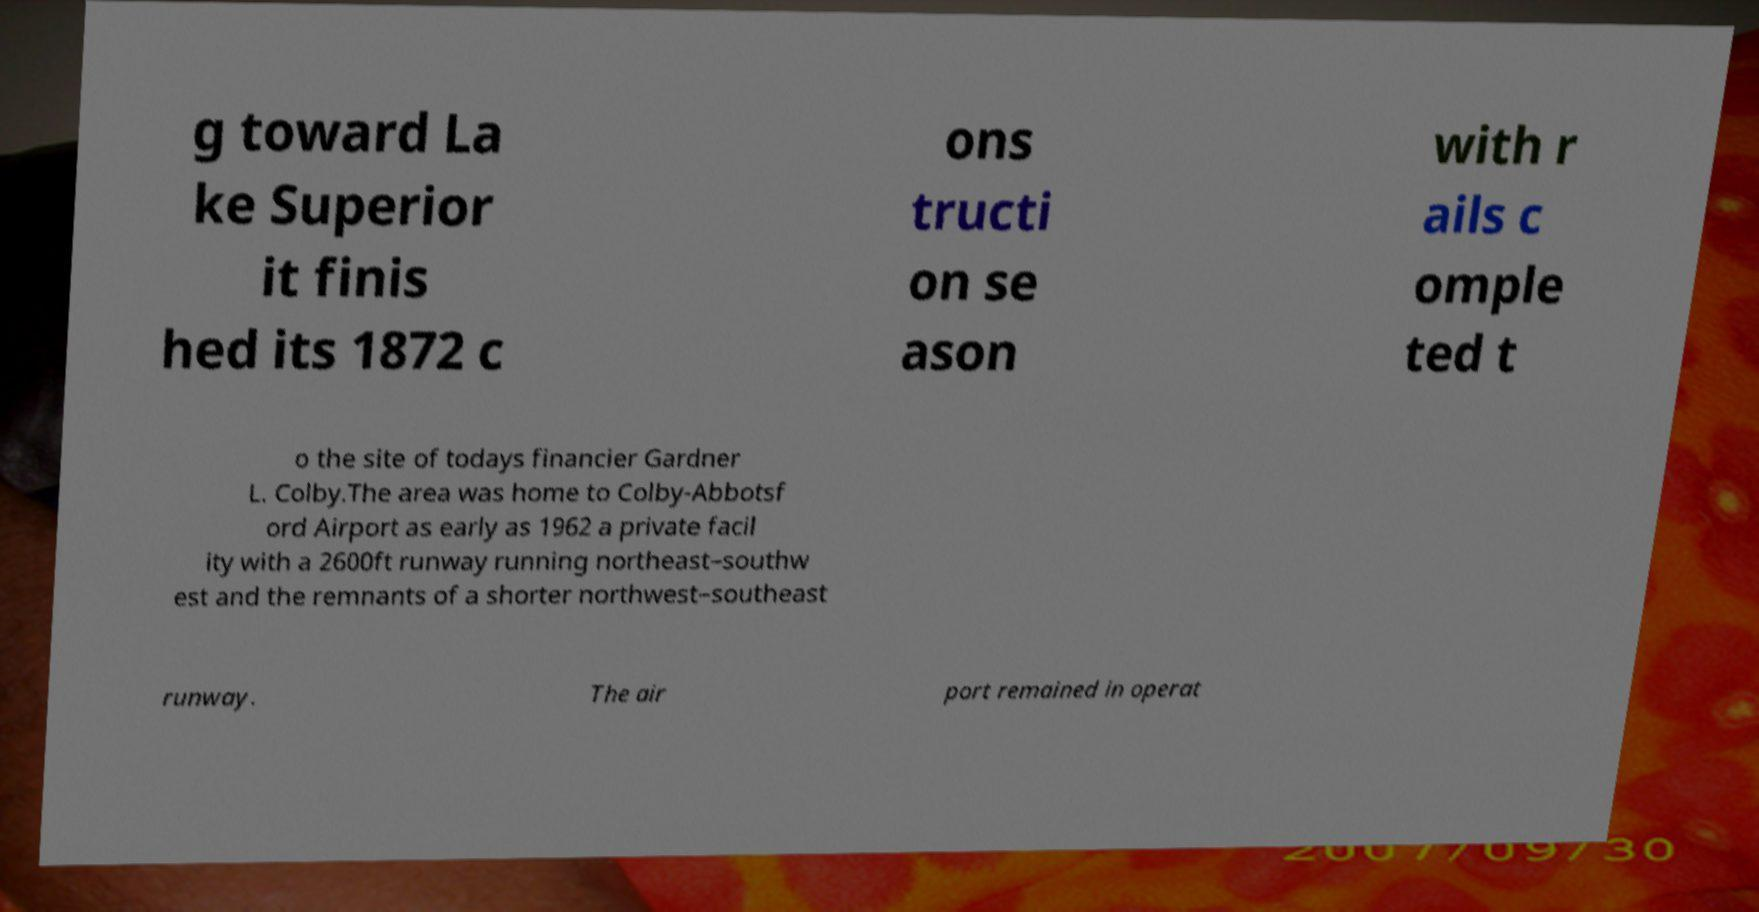Could you extract and type out the text from this image? g toward La ke Superior it finis hed its 1872 c ons tructi on se ason with r ails c omple ted t o the site of todays financier Gardner L. Colby.The area was home to Colby-Abbotsf ord Airport as early as 1962 a private facil ity with a 2600ft runway running northeast–southw est and the remnants of a shorter northwest–southeast runway. The air port remained in operat 